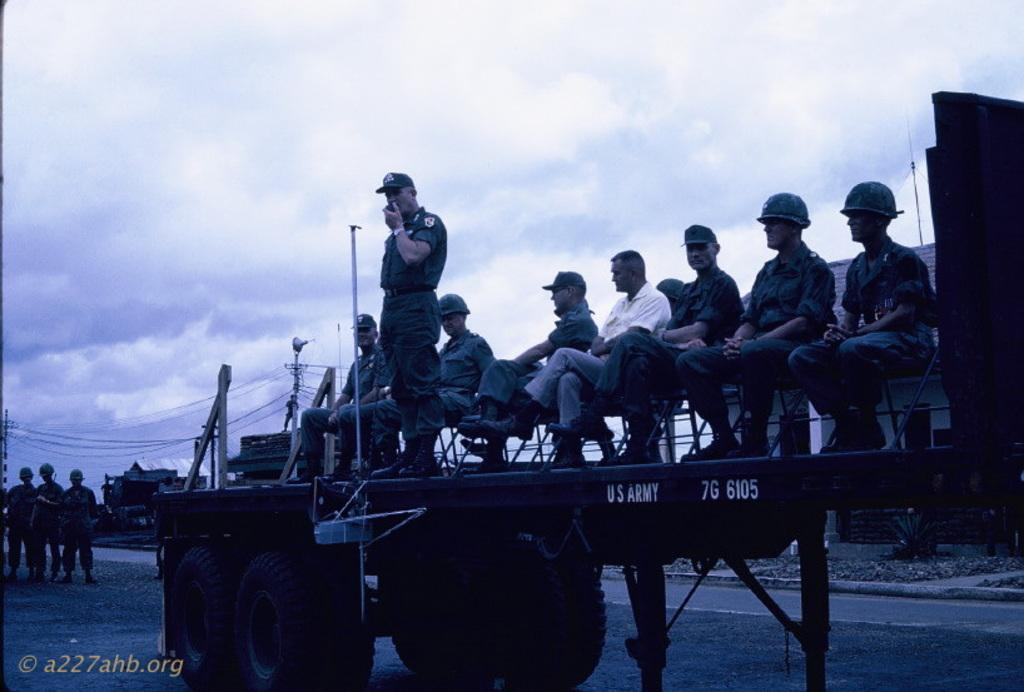What are the persons doing in the image? The persons are on a vehicle in the image. What else can be seen in the image besides the persons on the vehicle? There are poles, houses, and the sky with clouds visible in the background. How many persons are present in the image? There are three persons in the image. What type of competition is taking place in the image? There is no competition present in the image; it simply shows persons on a vehicle, poles, houses, and the sky with clouds. What material is the copper used for in the image? There is no copper present in the image. 